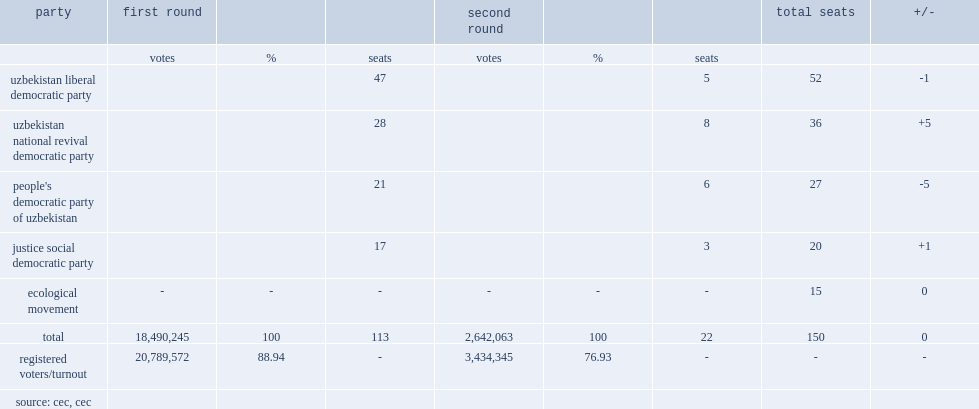How many seats were won by candidates in the first round? 113.0. 